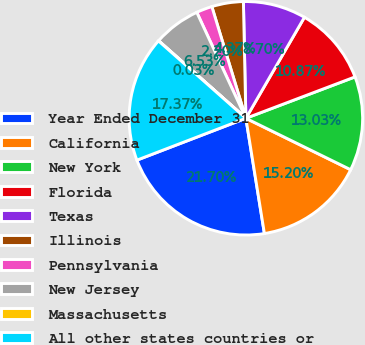<chart> <loc_0><loc_0><loc_500><loc_500><pie_chart><fcel>Year Ended December 31<fcel>California<fcel>New York<fcel>Florida<fcel>Texas<fcel>Illinois<fcel>Pennsylvania<fcel>New Jersey<fcel>Massachusetts<fcel>All other states countries or<nl><fcel>21.7%<fcel>15.2%<fcel>13.03%<fcel>10.87%<fcel>8.7%<fcel>4.37%<fcel>2.2%<fcel>6.53%<fcel>0.03%<fcel>17.37%<nl></chart> 